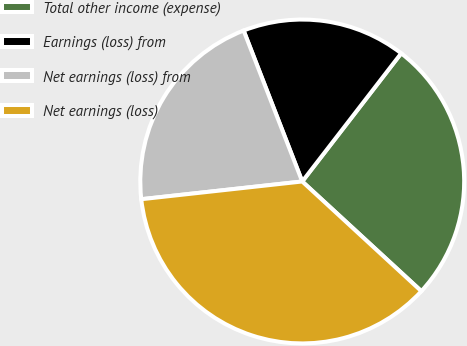Convert chart. <chart><loc_0><loc_0><loc_500><loc_500><pie_chart><fcel>Total other income (expense)<fcel>Earnings (loss) from<fcel>Net earnings (loss) from<fcel>Net earnings (loss)<nl><fcel>26.38%<fcel>16.36%<fcel>20.85%<fcel>36.41%<nl></chart> 